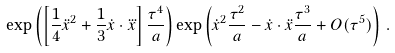<formula> <loc_0><loc_0><loc_500><loc_500>\exp \left ( \left [ \frac { 1 } { 4 } \ddot { x } ^ { 2 } + \frac { 1 } { 3 } \dot { x } \cdot \dddot { x } \right ] \frac { \tau ^ { 4 } } a \right ) \exp \left ( \dot { x } ^ { 2 } \frac { \tau ^ { 2 } } a - \dot { x } \cdot \ddot { x } \frac { \tau ^ { 3 } } a + O ( \tau ^ { 5 } ) \right ) \, .</formula> 